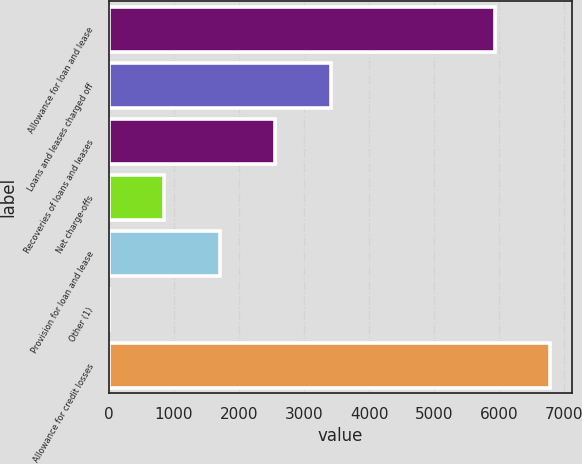<chart> <loc_0><loc_0><loc_500><loc_500><bar_chart><fcel>Allowance for loan and lease<fcel>Loans and leases charged off<fcel>Recoveries of loans and leases<fcel>Net charge-offs<fcel>Provision for loan and lease<fcel>Other (1)<fcel>Allowance for credit losses<nl><fcel>5935<fcel>3409.6<fcel>2558.2<fcel>855.4<fcel>1706.8<fcel>4<fcel>6786.4<nl></chart> 